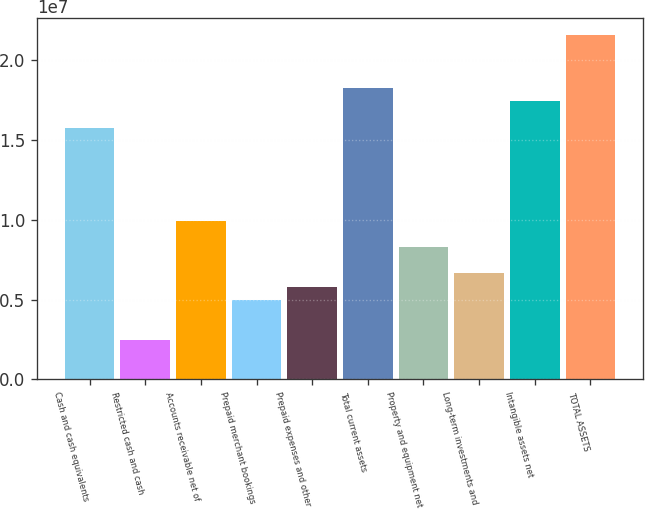Convert chart. <chart><loc_0><loc_0><loc_500><loc_500><bar_chart><fcel>Cash and cash equivalents<fcel>Restricted cash and cash<fcel>Accounts receivable net of<fcel>Prepaid merchant bookings<fcel>Prepaid expenses and other<fcel>Total current assets<fcel>Property and equipment net<fcel>Long-term investments and<fcel>Intangible assets net<fcel>TOTAL ASSETS<nl><fcel>1.57613e+07<fcel>2.48864e+06<fcel>9.9545e+06<fcel>4.97726e+06<fcel>5.8068e+06<fcel>1.82499e+07<fcel>8.29542e+06<fcel>6.63634e+06<fcel>1.74204e+07<fcel>2.15681e+07<nl></chart> 